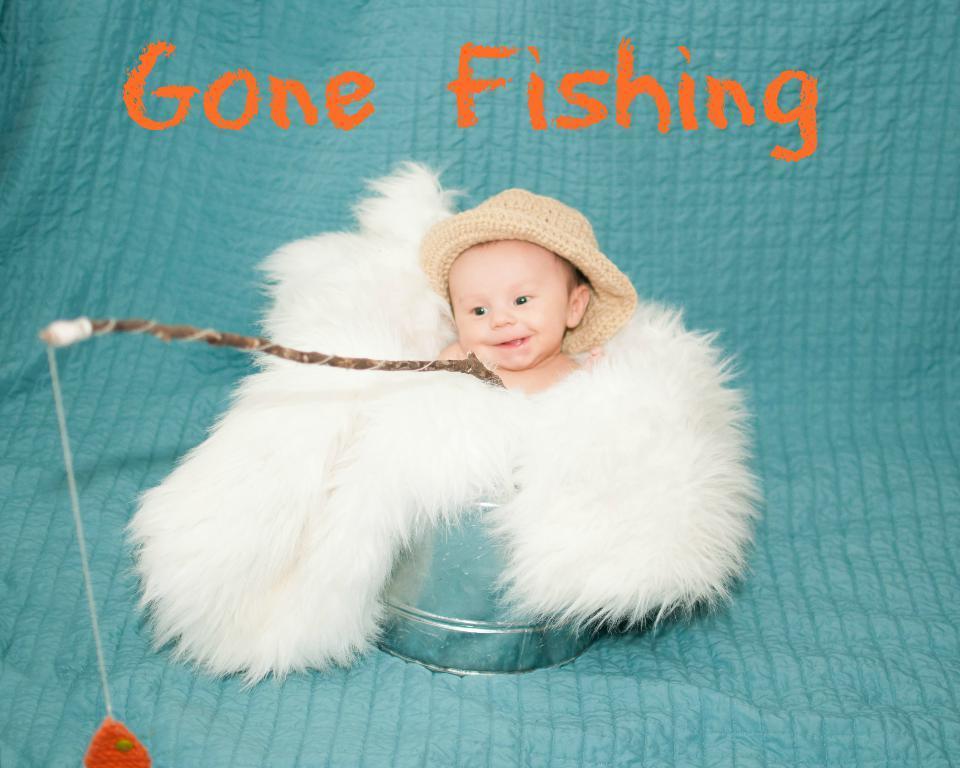Could you give a brief overview of what you see in this image? In this picture I can observe a baby in the middle of the picture. In front of the baby there is a fishing stick. The baby is smiling. In the top of the picture I can observe an orange color text. 